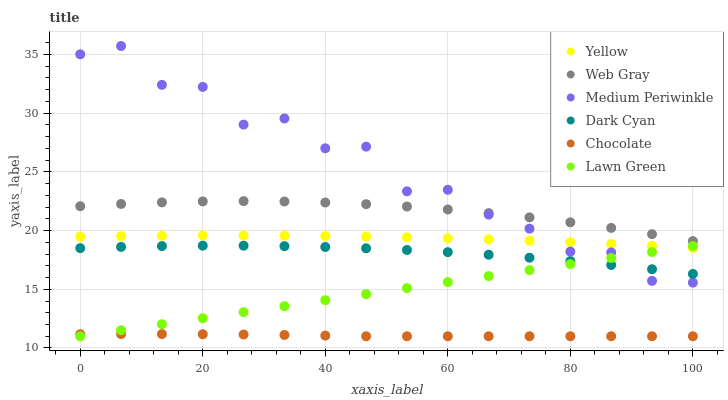Does Chocolate have the minimum area under the curve?
Answer yes or no. Yes. Does Medium Periwinkle have the maximum area under the curve?
Answer yes or no. Yes. Does Web Gray have the minimum area under the curve?
Answer yes or no. No. Does Web Gray have the maximum area under the curve?
Answer yes or no. No. Is Lawn Green the smoothest?
Answer yes or no. Yes. Is Medium Periwinkle the roughest?
Answer yes or no. Yes. Is Web Gray the smoothest?
Answer yes or no. No. Is Web Gray the roughest?
Answer yes or no. No. Does Lawn Green have the lowest value?
Answer yes or no. Yes. Does Medium Periwinkle have the lowest value?
Answer yes or no. No. Does Medium Periwinkle have the highest value?
Answer yes or no. Yes. Does Web Gray have the highest value?
Answer yes or no. No. Is Dark Cyan less than Yellow?
Answer yes or no. Yes. Is Web Gray greater than Dark Cyan?
Answer yes or no. Yes. Does Chocolate intersect Lawn Green?
Answer yes or no. Yes. Is Chocolate less than Lawn Green?
Answer yes or no. No. Is Chocolate greater than Lawn Green?
Answer yes or no. No. Does Dark Cyan intersect Yellow?
Answer yes or no. No. 